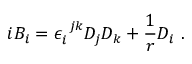<formula> <loc_0><loc_0><loc_500><loc_500>i B _ { i } = \epsilon _ { i } ^ { j k } D _ { j } D _ { k } + \frac { 1 } { r } D _ { i } .</formula> 